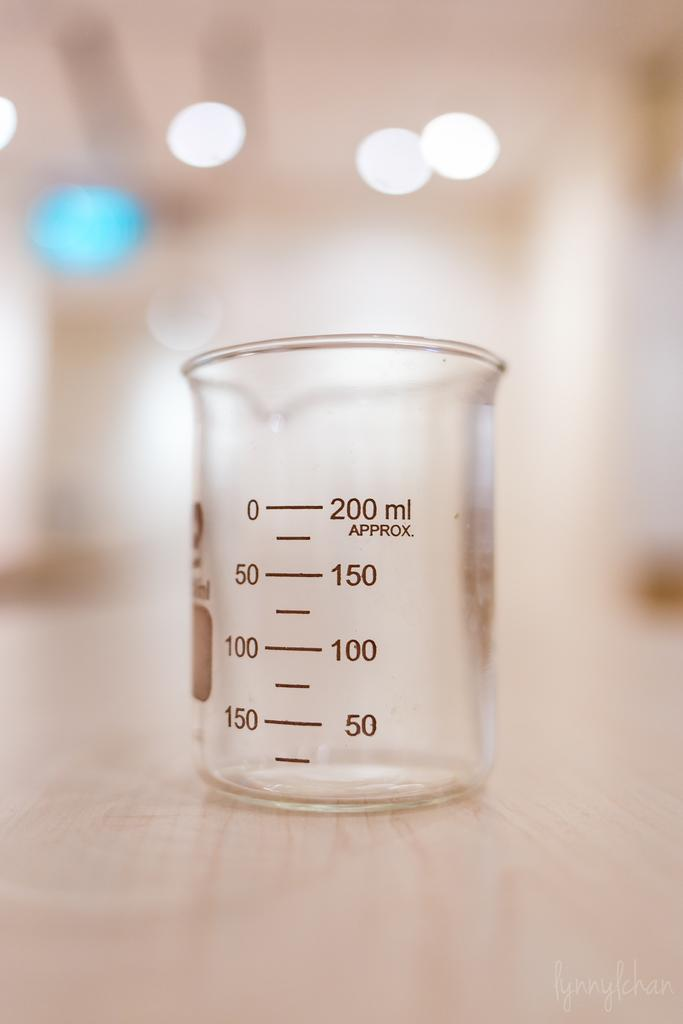<image>
Write a terse but informative summary of the picture. A glass jar that has markings up to 200 ml. 